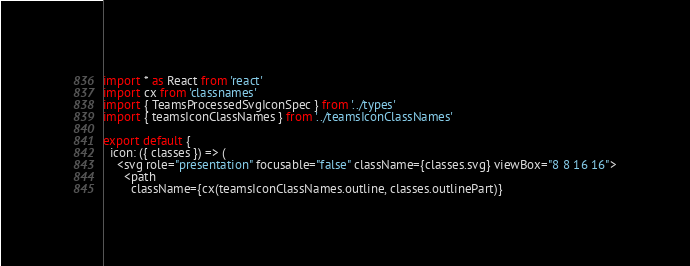<code> <loc_0><loc_0><loc_500><loc_500><_TypeScript_>import * as React from 'react'
import cx from 'classnames'
import { TeamsProcessedSvgIconSpec } from '../types'
import { teamsIconClassNames } from '../teamsIconClassNames'

export default {
  icon: ({ classes }) => (
    <svg role="presentation" focusable="false" className={classes.svg} viewBox="8 8 16 16">
      <path
        className={cx(teamsIconClassNames.outline, classes.outlinePart)}</code> 